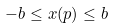Convert formula to latex. <formula><loc_0><loc_0><loc_500><loc_500>- b \leq x ( p ) \leq b</formula> 